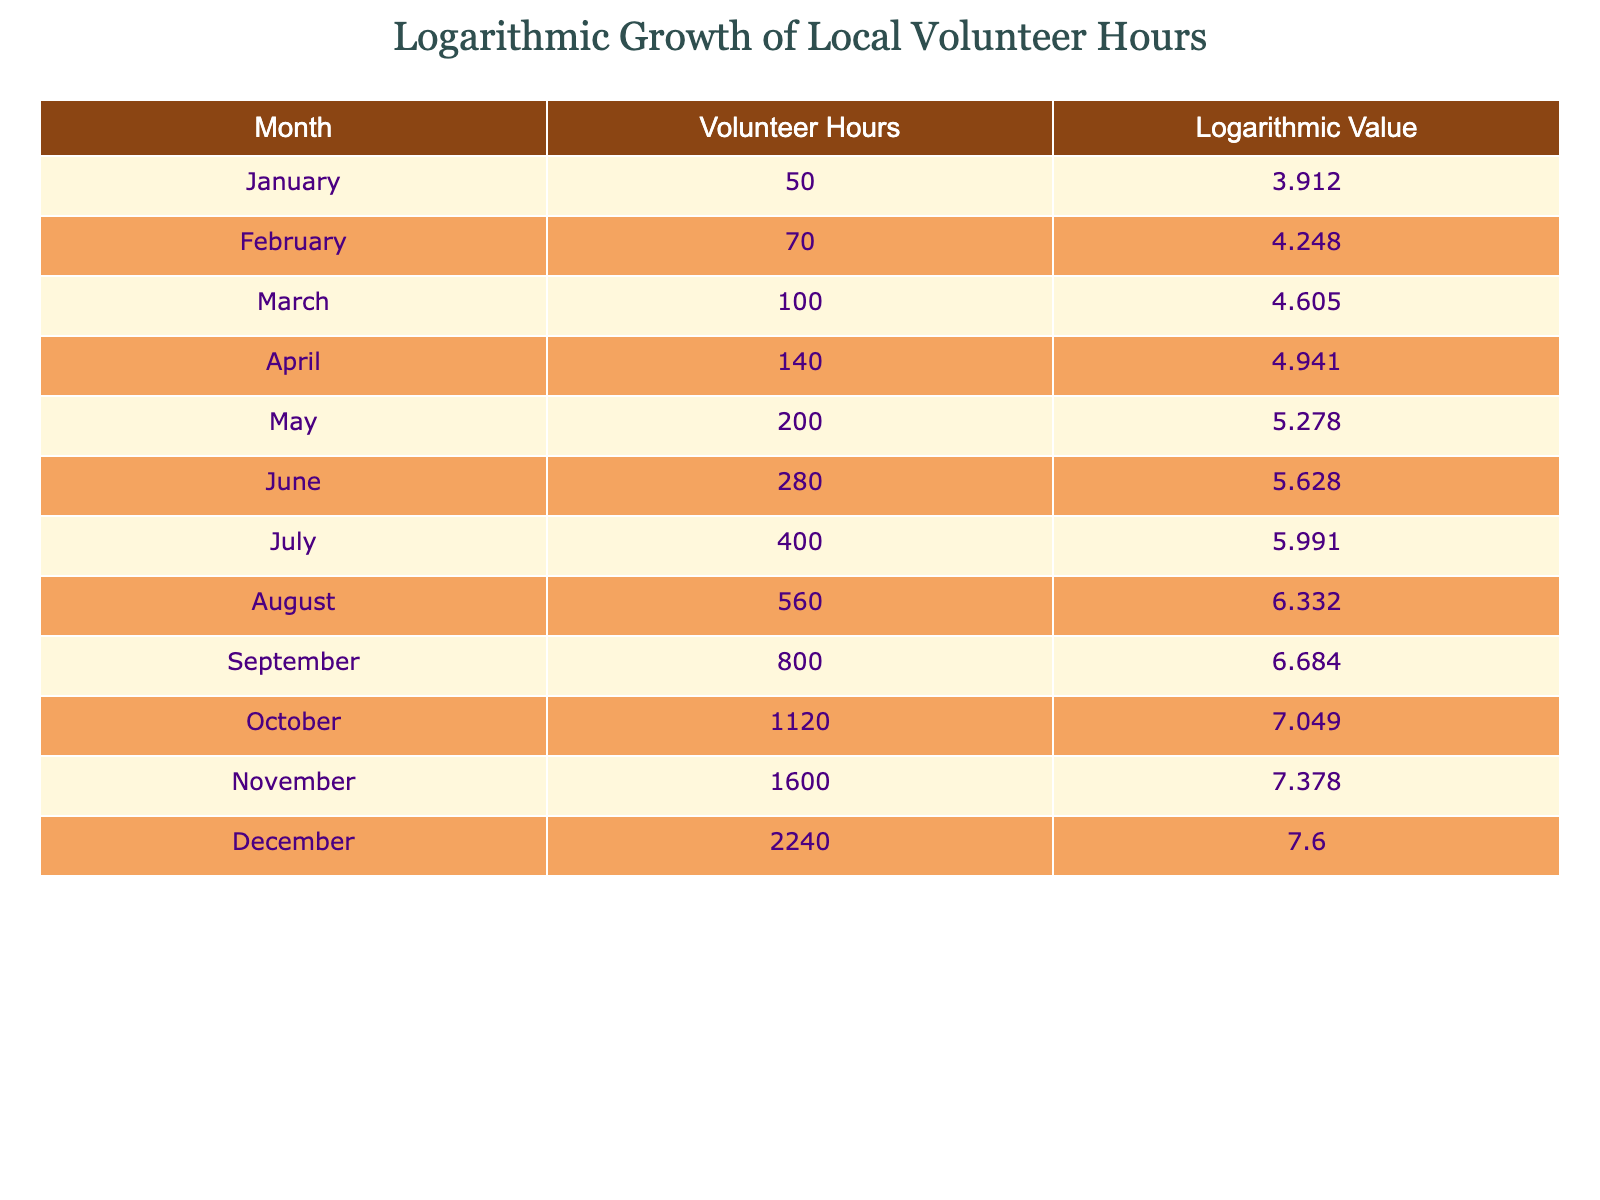What is the total number of volunteer hours in December? From the table, the volunteer hours for December is directly listed as 2240.
Answer: 2240 What was the logarithmic value for March? The logarithmic value for March is found directly in the table, which states it is 4.605.
Answer: 4.605 In which month did the volunteer hours exceed 600? By examining the volunteer hours listed, August (560) is the closest to 600, while September has 800 hours, which exceeds 600.
Answer: September How much did the volunteer hours increase from October to November? The volunteer hours in October are 1120, and in November they are 1600. The difference is 1600 - 1120 = 480.
Answer: 480 What is the average volunteer hours for the first half of the year (January to June)? The volunteer hours for January to June are 50, 70, 100, 140, 200, and 280. Adding these gives 50 + 70 + 100 + 140 + 200 + 280 = 840. There are 6 months, so the average is 840 / 6 = 140.
Answer: 140 Do the logarithmic values increase steadily throughout the year? Examining the logarithmic values, they show a consistent increase from 3.912 in January to 7.600 in December, indicating a steady increase.
Answer: Yes Which month has the highest number of volunteer hours and what is the value? December has the highest number of volunteer hours, which is noted in the table as 2240.
Answer: December, 2240 If we compare the volunteer hours in April and October, which month had more hours and by how much? April has 140 hours while October has 1120 hours. Therefore, October has 1120 - 140 = 980 more hours than April.
Answer: October, 980 What was the difference in logarithmic value between January and December? The logarithmic value for January is 3.912 and for December it is 7.600. The difference is 7.600 - 3.912 = 3.688.
Answer: 3.688 